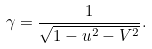<formula> <loc_0><loc_0><loc_500><loc_500>\gamma = \frac { 1 } { \sqrt { 1 - u ^ { 2 } - V ^ { 2 } } } .</formula> 